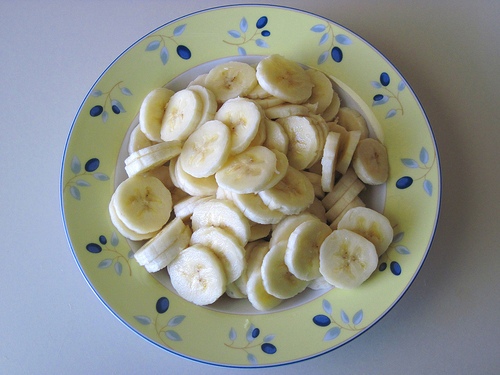<image>
Is there a plate next to the bananas? No. The plate is not positioned next to the bananas. They are located in different areas of the scene. 